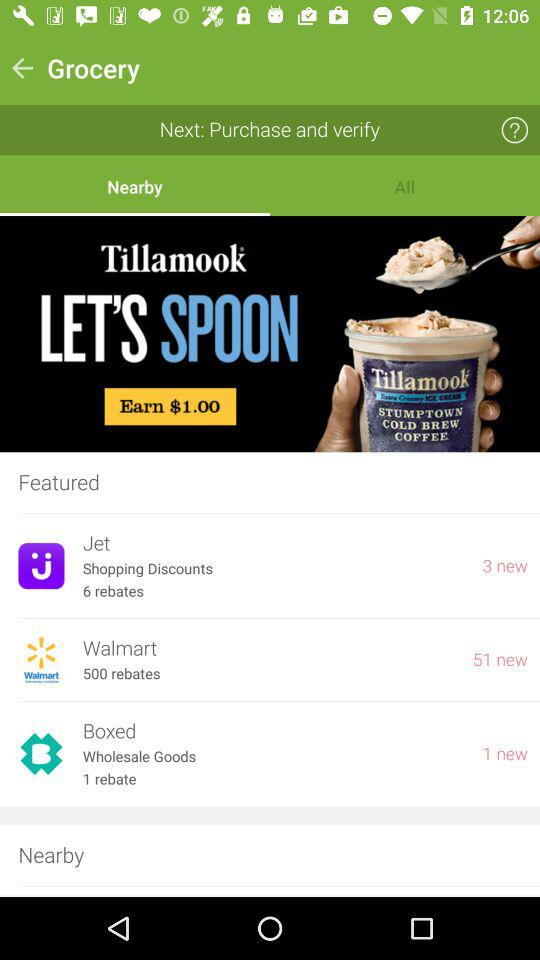Which company is providing 500 rebates? The company that is providing 500 rebates is Walmart. 